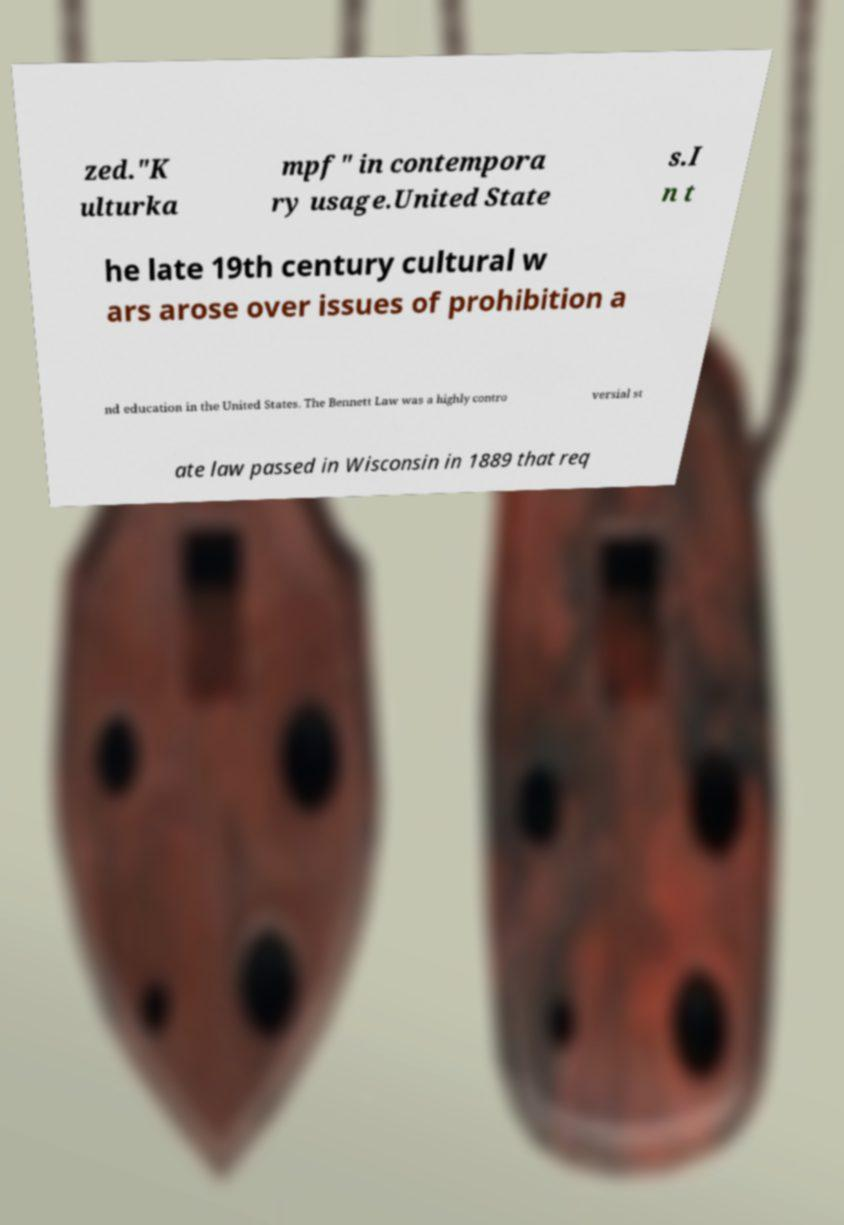Can you read and provide the text displayed in the image?This photo seems to have some interesting text. Can you extract and type it out for me? zed."K ulturka mpf" in contempora ry usage.United State s.I n t he late 19th century cultural w ars arose over issues of prohibition a nd education in the United States. The Bennett Law was a highly contro versial st ate law passed in Wisconsin in 1889 that req 